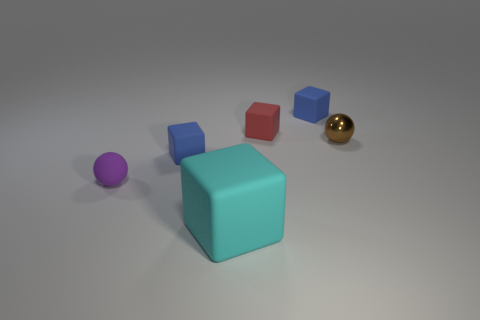Add 1 purple spheres. How many objects exist? 7 Subtract all cubes. How many objects are left? 2 Subtract all small brown spheres. Subtract all small shiny balls. How many objects are left? 4 Add 2 small blue rubber things. How many small blue rubber things are left? 4 Add 1 shiny things. How many shiny things exist? 2 Subtract 0 cyan balls. How many objects are left? 6 